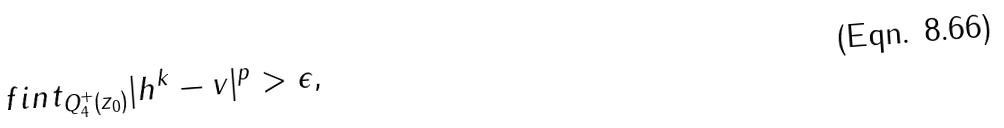<formula> <loc_0><loc_0><loc_500><loc_500>\ f i n t _ { Q _ { 4 } ^ { + } ( z _ { 0 } ) } | h ^ { k } - v | ^ { p } > \epsilon ,</formula> 